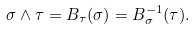Convert formula to latex. <formula><loc_0><loc_0><loc_500><loc_500>\sigma \wedge \tau = B _ { \tau } ( \sigma ) = B ^ { - 1 } _ { \sigma } ( \tau ) .</formula> 